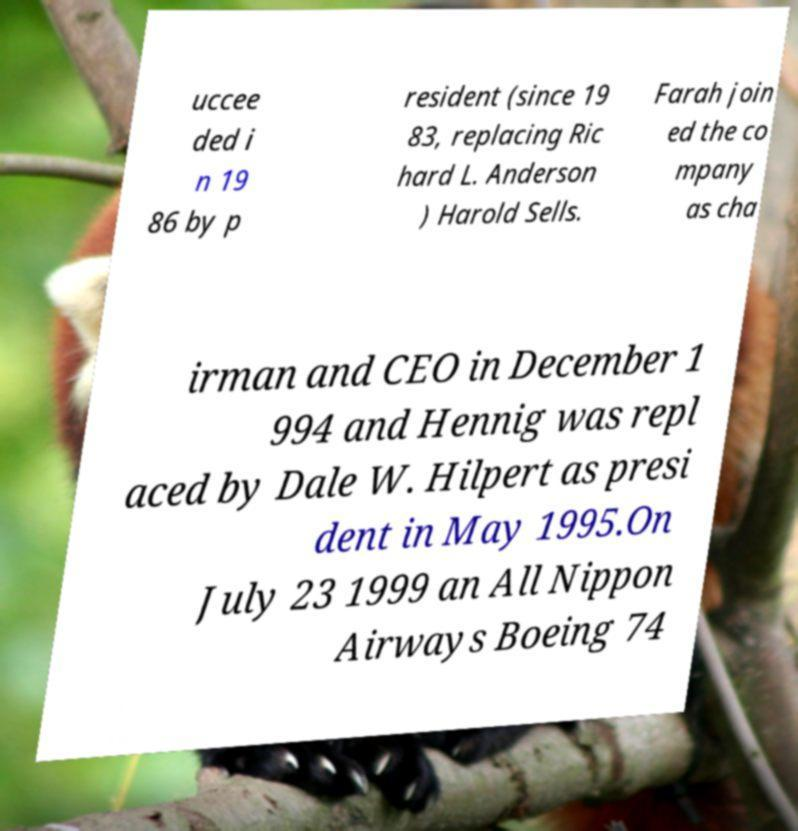Could you assist in decoding the text presented in this image and type it out clearly? uccee ded i n 19 86 by p resident (since 19 83, replacing Ric hard L. Anderson ) Harold Sells. Farah join ed the co mpany as cha irman and CEO in December 1 994 and Hennig was repl aced by Dale W. Hilpert as presi dent in May 1995.On July 23 1999 an All Nippon Airways Boeing 74 